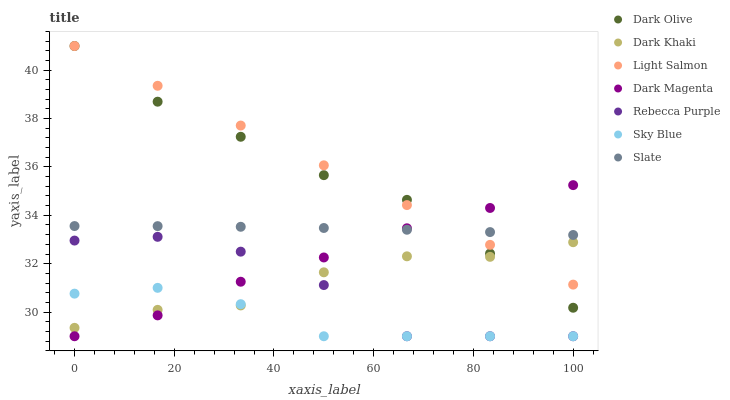Does Sky Blue have the minimum area under the curve?
Answer yes or no. Yes. Does Light Salmon have the maximum area under the curve?
Answer yes or no. Yes. Does Dark Magenta have the minimum area under the curve?
Answer yes or no. No. Does Dark Magenta have the maximum area under the curve?
Answer yes or no. No. Is Light Salmon the smoothest?
Answer yes or no. Yes. Is Rebecca Purple the roughest?
Answer yes or no. Yes. Is Dark Magenta the smoothest?
Answer yes or no. No. Is Dark Magenta the roughest?
Answer yes or no. No. Does Dark Magenta have the lowest value?
Answer yes or no. Yes. Does Slate have the lowest value?
Answer yes or no. No. Does Dark Olive have the highest value?
Answer yes or no. Yes. Does Dark Magenta have the highest value?
Answer yes or no. No. Is Sky Blue less than Dark Olive?
Answer yes or no. Yes. Is Light Salmon greater than Sky Blue?
Answer yes or no. Yes. Does Dark Olive intersect Dark Magenta?
Answer yes or no. Yes. Is Dark Olive less than Dark Magenta?
Answer yes or no. No. Is Dark Olive greater than Dark Magenta?
Answer yes or no. No. Does Sky Blue intersect Dark Olive?
Answer yes or no. No. 